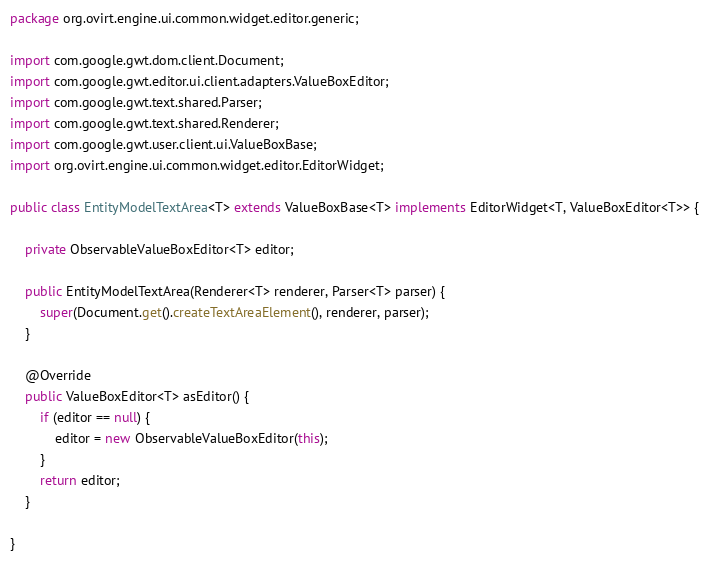<code> <loc_0><loc_0><loc_500><loc_500><_Java_>package org.ovirt.engine.ui.common.widget.editor.generic;

import com.google.gwt.dom.client.Document;
import com.google.gwt.editor.ui.client.adapters.ValueBoxEditor;
import com.google.gwt.text.shared.Parser;
import com.google.gwt.text.shared.Renderer;
import com.google.gwt.user.client.ui.ValueBoxBase;
import org.ovirt.engine.ui.common.widget.editor.EditorWidget;

public class EntityModelTextArea<T> extends ValueBoxBase<T> implements EditorWidget<T, ValueBoxEditor<T>> {

    private ObservableValueBoxEditor<T> editor;

    public EntityModelTextArea(Renderer<T> renderer, Parser<T> parser) {
        super(Document.get().createTextAreaElement(), renderer, parser);
    }

    @Override
    public ValueBoxEditor<T> asEditor() {
        if (editor == null) {
            editor = new ObservableValueBoxEditor(this);
        }
        return editor;
    }

}
</code> 